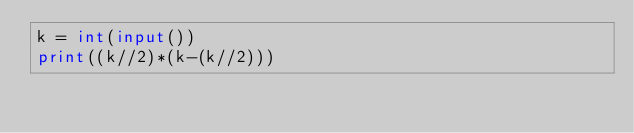<code> <loc_0><loc_0><loc_500><loc_500><_Python_>k = int(input())
print((k//2)*(k-(k//2)))</code> 